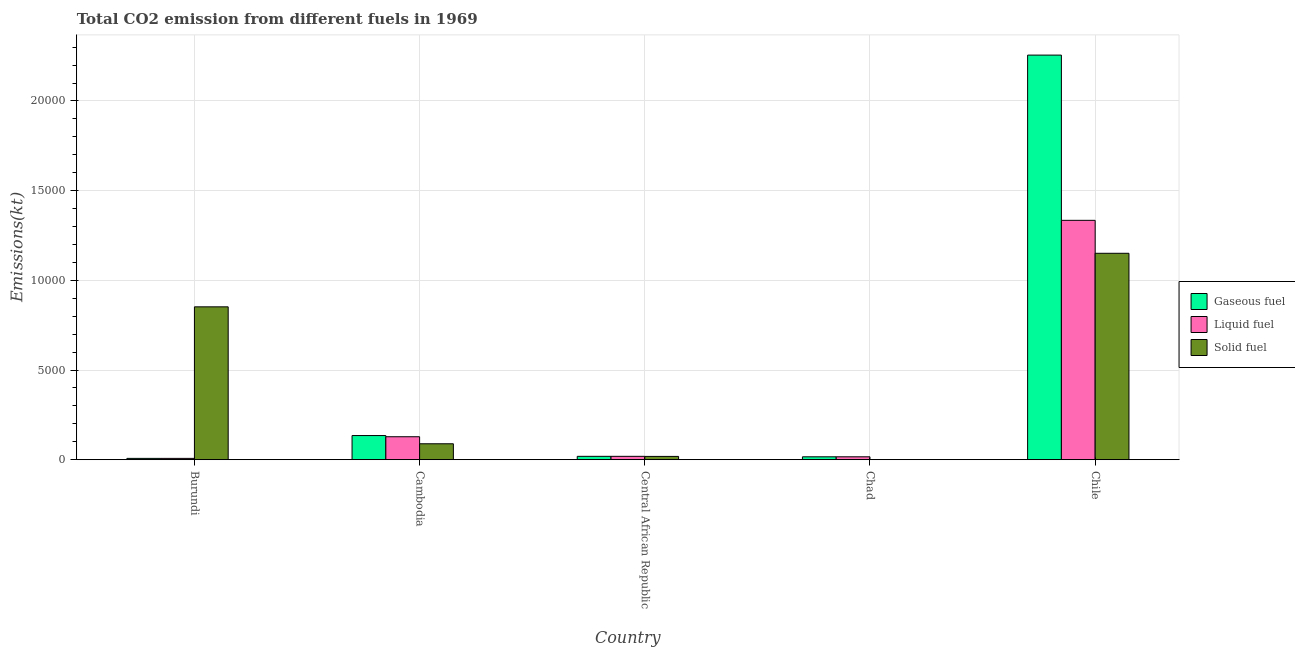How many different coloured bars are there?
Provide a short and direct response. 3. Are the number of bars per tick equal to the number of legend labels?
Keep it short and to the point. Yes. How many bars are there on the 2nd tick from the right?
Your response must be concise. 3. What is the amount of co2 emissions from solid fuel in Chile?
Your answer should be compact. 1.15e+04. Across all countries, what is the maximum amount of co2 emissions from solid fuel?
Your answer should be very brief. 1.15e+04. Across all countries, what is the minimum amount of co2 emissions from gaseous fuel?
Keep it short and to the point. 73.34. In which country was the amount of co2 emissions from gaseous fuel maximum?
Keep it short and to the point. Chile. In which country was the amount of co2 emissions from gaseous fuel minimum?
Your answer should be very brief. Burundi. What is the total amount of co2 emissions from liquid fuel in the graph?
Your answer should be very brief. 1.50e+04. What is the difference between the amount of co2 emissions from solid fuel in Central African Republic and that in Chile?
Ensure brevity in your answer.  -1.13e+04. What is the difference between the amount of co2 emissions from liquid fuel in Cambodia and the amount of co2 emissions from solid fuel in Burundi?
Offer a very short reply. -7242.33. What is the average amount of co2 emissions from solid fuel per country?
Keep it short and to the point. 4220.72. What is the difference between the amount of co2 emissions from gaseous fuel and amount of co2 emissions from solid fuel in Burundi?
Your answer should be very brief. -8448.77. In how many countries, is the amount of co2 emissions from liquid fuel greater than 19000 kt?
Provide a short and direct response. 0. What is the ratio of the amount of co2 emissions from gaseous fuel in Cambodia to that in Central African Republic?
Offer a terse response. 7.2. What is the difference between the highest and the second highest amount of co2 emissions from gaseous fuel?
Your answer should be very brief. 2.12e+04. What is the difference between the highest and the lowest amount of co2 emissions from liquid fuel?
Keep it short and to the point. 1.33e+04. What does the 1st bar from the left in Central African Republic represents?
Your answer should be very brief. Gaseous fuel. What does the 1st bar from the right in Cambodia represents?
Provide a short and direct response. Solid fuel. Is it the case that in every country, the sum of the amount of co2 emissions from gaseous fuel and amount of co2 emissions from liquid fuel is greater than the amount of co2 emissions from solid fuel?
Offer a terse response. No. How many bars are there?
Give a very brief answer. 15. How many countries are there in the graph?
Your response must be concise. 5. Does the graph contain any zero values?
Offer a terse response. No. Does the graph contain grids?
Your answer should be very brief. Yes. Where does the legend appear in the graph?
Keep it short and to the point. Center right. How many legend labels are there?
Your answer should be compact. 3. How are the legend labels stacked?
Offer a terse response. Vertical. What is the title of the graph?
Your response must be concise. Total CO2 emission from different fuels in 1969. What is the label or title of the X-axis?
Your answer should be very brief. Country. What is the label or title of the Y-axis?
Provide a short and direct response. Emissions(kt). What is the Emissions(kt) in Gaseous fuel in Burundi?
Your answer should be very brief. 73.34. What is the Emissions(kt) in Liquid fuel in Burundi?
Your answer should be very brief. 73.34. What is the Emissions(kt) of Solid fuel in Burundi?
Ensure brevity in your answer.  8522.11. What is the Emissions(kt) of Gaseous fuel in Cambodia?
Provide a short and direct response. 1345.79. What is the Emissions(kt) of Liquid fuel in Cambodia?
Offer a very short reply. 1279.78. What is the Emissions(kt) in Solid fuel in Cambodia?
Offer a very short reply. 887.41. What is the Emissions(kt) in Gaseous fuel in Central African Republic?
Make the answer very short. 187.02. What is the Emissions(kt) in Liquid fuel in Central African Republic?
Offer a terse response. 187.02. What is the Emissions(kt) of Solid fuel in Central African Republic?
Your answer should be compact. 183.35. What is the Emissions(kt) of Gaseous fuel in Chad?
Give a very brief answer. 161.35. What is the Emissions(kt) of Liquid fuel in Chad?
Your answer should be compact. 161.35. What is the Emissions(kt) of Solid fuel in Chad?
Keep it short and to the point. 3.67. What is the Emissions(kt) in Gaseous fuel in Chile?
Give a very brief answer. 2.26e+04. What is the Emissions(kt) of Liquid fuel in Chile?
Offer a terse response. 1.33e+04. What is the Emissions(kt) of Solid fuel in Chile?
Offer a very short reply. 1.15e+04. Across all countries, what is the maximum Emissions(kt) of Gaseous fuel?
Provide a succinct answer. 2.26e+04. Across all countries, what is the maximum Emissions(kt) of Liquid fuel?
Provide a succinct answer. 1.33e+04. Across all countries, what is the maximum Emissions(kt) of Solid fuel?
Give a very brief answer. 1.15e+04. Across all countries, what is the minimum Emissions(kt) of Gaseous fuel?
Your response must be concise. 73.34. Across all countries, what is the minimum Emissions(kt) in Liquid fuel?
Give a very brief answer. 73.34. Across all countries, what is the minimum Emissions(kt) in Solid fuel?
Give a very brief answer. 3.67. What is the total Emissions(kt) in Gaseous fuel in the graph?
Your answer should be very brief. 2.43e+04. What is the total Emissions(kt) of Liquid fuel in the graph?
Your answer should be very brief. 1.50e+04. What is the total Emissions(kt) of Solid fuel in the graph?
Keep it short and to the point. 2.11e+04. What is the difference between the Emissions(kt) of Gaseous fuel in Burundi and that in Cambodia?
Provide a short and direct response. -1272.45. What is the difference between the Emissions(kt) of Liquid fuel in Burundi and that in Cambodia?
Your answer should be compact. -1206.44. What is the difference between the Emissions(kt) in Solid fuel in Burundi and that in Cambodia?
Your answer should be compact. 7634.69. What is the difference between the Emissions(kt) of Gaseous fuel in Burundi and that in Central African Republic?
Offer a terse response. -113.68. What is the difference between the Emissions(kt) of Liquid fuel in Burundi and that in Central African Republic?
Your answer should be very brief. -113.68. What is the difference between the Emissions(kt) of Solid fuel in Burundi and that in Central African Republic?
Your answer should be compact. 8338.76. What is the difference between the Emissions(kt) in Gaseous fuel in Burundi and that in Chad?
Make the answer very short. -88.01. What is the difference between the Emissions(kt) in Liquid fuel in Burundi and that in Chad?
Give a very brief answer. -88.01. What is the difference between the Emissions(kt) of Solid fuel in Burundi and that in Chad?
Ensure brevity in your answer.  8518.44. What is the difference between the Emissions(kt) in Gaseous fuel in Burundi and that in Chile?
Offer a terse response. -2.25e+04. What is the difference between the Emissions(kt) in Liquid fuel in Burundi and that in Chile?
Give a very brief answer. -1.33e+04. What is the difference between the Emissions(kt) of Solid fuel in Burundi and that in Chile?
Make the answer very short. -2984.94. What is the difference between the Emissions(kt) in Gaseous fuel in Cambodia and that in Central African Republic?
Your response must be concise. 1158.77. What is the difference between the Emissions(kt) in Liquid fuel in Cambodia and that in Central African Republic?
Offer a terse response. 1092.77. What is the difference between the Emissions(kt) of Solid fuel in Cambodia and that in Central African Republic?
Offer a very short reply. 704.06. What is the difference between the Emissions(kt) of Gaseous fuel in Cambodia and that in Chad?
Ensure brevity in your answer.  1184.44. What is the difference between the Emissions(kt) of Liquid fuel in Cambodia and that in Chad?
Offer a terse response. 1118.43. What is the difference between the Emissions(kt) in Solid fuel in Cambodia and that in Chad?
Offer a terse response. 883.75. What is the difference between the Emissions(kt) in Gaseous fuel in Cambodia and that in Chile?
Your answer should be compact. -2.12e+04. What is the difference between the Emissions(kt) of Liquid fuel in Cambodia and that in Chile?
Your answer should be very brief. -1.21e+04. What is the difference between the Emissions(kt) in Solid fuel in Cambodia and that in Chile?
Offer a very short reply. -1.06e+04. What is the difference between the Emissions(kt) of Gaseous fuel in Central African Republic and that in Chad?
Your answer should be compact. 25.67. What is the difference between the Emissions(kt) in Liquid fuel in Central African Republic and that in Chad?
Offer a very short reply. 25.67. What is the difference between the Emissions(kt) in Solid fuel in Central African Republic and that in Chad?
Provide a succinct answer. 179.68. What is the difference between the Emissions(kt) in Gaseous fuel in Central African Republic and that in Chile?
Ensure brevity in your answer.  -2.24e+04. What is the difference between the Emissions(kt) in Liquid fuel in Central African Republic and that in Chile?
Make the answer very short. -1.32e+04. What is the difference between the Emissions(kt) of Solid fuel in Central African Republic and that in Chile?
Provide a succinct answer. -1.13e+04. What is the difference between the Emissions(kt) of Gaseous fuel in Chad and that in Chile?
Give a very brief answer. -2.24e+04. What is the difference between the Emissions(kt) of Liquid fuel in Chad and that in Chile?
Make the answer very short. -1.32e+04. What is the difference between the Emissions(kt) of Solid fuel in Chad and that in Chile?
Your answer should be very brief. -1.15e+04. What is the difference between the Emissions(kt) in Gaseous fuel in Burundi and the Emissions(kt) in Liquid fuel in Cambodia?
Provide a short and direct response. -1206.44. What is the difference between the Emissions(kt) in Gaseous fuel in Burundi and the Emissions(kt) in Solid fuel in Cambodia?
Provide a succinct answer. -814.07. What is the difference between the Emissions(kt) in Liquid fuel in Burundi and the Emissions(kt) in Solid fuel in Cambodia?
Your answer should be compact. -814.07. What is the difference between the Emissions(kt) of Gaseous fuel in Burundi and the Emissions(kt) of Liquid fuel in Central African Republic?
Offer a very short reply. -113.68. What is the difference between the Emissions(kt) in Gaseous fuel in Burundi and the Emissions(kt) in Solid fuel in Central African Republic?
Ensure brevity in your answer.  -110.01. What is the difference between the Emissions(kt) in Liquid fuel in Burundi and the Emissions(kt) in Solid fuel in Central African Republic?
Provide a short and direct response. -110.01. What is the difference between the Emissions(kt) of Gaseous fuel in Burundi and the Emissions(kt) of Liquid fuel in Chad?
Your response must be concise. -88.01. What is the difference between the Emissions(kt) in Gaseous fuel in Burundi and the Emissions(kt) in Solid fuel in Chad?
Provide a succinct answer. 69.67. What is the difference between the Emissions(kt) of Liquid fuel in Burundi and the Emissions(kt) of Solid fuel in Chad?
Your answer should be compact. 69.67. What is the difference between the Emissions(kt) of Gaseous fuel in Burundi and the Emissions(kt) of Liquid fuel in Chile?
Make the answer very short. -1.33e+04. What is the difference between the Emissions(kt) in Gaseous fuel in Burundi and the Emissions(kt) in Solid fuel in Chile?
Keep it short and to the point. -1.14e+04. What is the difference between the Emissions(kt) of Liquid fuel in Burundi and the Emissions(kt) of Solid fuel in Chile?
Provide a succinct answer. -1.14e+04. What is the difference between the Emissions(kt) of Gaseous fuel in Cambodia and the Emissions(kt) of Liquid fuel in Central African Republic?
Provide a short and direct response. 1158.77. What is the difference between the Emissions(kt) of Gaseous fuel in Cambodia and the Emissions(kt) of Solid fuel in Central African Republic?
Provide a short and direct response. 1162.44. What is the difference between the Emissions(kt) in Liquid fuel in Cambodia and the Emissions(kt) in Solid fuel in Central African Republic?
Make the answer very short. 1096.43. What is the difference between the Emissions(kt) in Gaseous fuel in Cambodia and the Emissions(kt) in Liquid fuel in Chad?
Provide a succinct answer. 1184.44. What is the difference between the Emissions(kt) of Gaseous fuel in Cambodia and the Emissions(kt) of Solid fuel in Chad?
Keep it short and to the point. 1342.12. What is the difference between the Emissions(kt) of Liquid fuel in Cambodia and the Emissions(kt) of Solid fuel in Chad?
Provide a short and direct response. 1276.12. What is the difference between the Emissions(kt) in Gaseous fuel in Cambodia and the Emissions(kt) in Liquid fuel in Chile?
Your answer should be very brief. -1.20e+04. What is the difference between the Emissions(kt) in Gaseous fuel in Cambodia and the Emissions(kt) in Solid fuel in Chile?
Ensure brevity in your answer.  -1.02e+04. What is the difference between the Emissions(kt) in Liquid fuel in Cambodia and the Emissions(kt) in Solid fuel in Chile?
Your answer should be compact. -1.02e+04. What is the difference between the Emissions(kt) in Gaseous fuel in Central African Republic and the Emissions(kt) in Liquid fuel in Chad?
Your answer should be compact. 25.67. What is the difference between the Emissions(kt) in Gaseous fuel in Central African Republic and the Emissions(kt) in Solid fuel in Chad?
Ensure brevity in your answer.  183.35. What is the difference between the Emissions(kt) of Liquid fuel in Central African Republic and the Emissions(kt) of Solid fuel in Chad?
Your answer should be compact. 183.35. What is the difference between the Emissions(kt) of Gaseous fuel in Central African Republic and the Emissions(kt) of Liquid fuel in Chile?
Ensure brevity in your answer.  -1.32e+04. What is the difference between the Emissions(kt) in Gaseous fuel in Central African Republic and the Emissions(kt) in Solid fuel in Chile?
Offer a terse response. -1.13e+04. What is the difference between the Emissions(kt) in Liquid fuel in Central African Republic and the Emissions(kt) in Solid fuel in Chile?
Your answer should be very brief. -1.13e+04. What is the difference between the Emissions(kt) in Gaseous fuel in Chad and the Emissions(kt) in Liquid fuel in Chile?
Provide a short and direct response. -1.32e+04. What is the difference between the Emissions(kt) in Gaseous fuel in Chad and the Emissions(kt) in Solid fuel in Chile?
Provide a succinct answer. -1.13e+04. What is the difference between the Emissions(kt) of Liquid fuel in Chad and the Emissions(kt) of Solid fuel in Chile?
Your answer should be very brief. -1.13e+04. What is the average Emissions(kt) of Gaseous fuel per country?
Offer a terse response. 4864.64. What is the average Emissions(kt) of Liquid fuel per country?
Make the answer very short. 3009.14. What is the average Emissions(kt) of Solid fuel per country?
Give a very brief answer. 4220.72. What is the difference between the Emissions(kt) of Gaseous fuel and Emissions(kt) of Solid fuel in Burundi?
Keep it short and to the point. -8448.77. What is the difference between the Emissions(kt) of Liquid fuel and Emissions(kt) of Solid fuel in Burundi?
Keep it short and to the point. -8448.77. What is the difference between the Emissions(kt) of Gaseous fuel and Emissions(kt) of Liquid fuel in Cambodia?
Make the answer very short. 66.01. What is the difference between the Emissions(kt) of Gaseous fuel and Emissions(kt) of Solid fuel in Cambodia?
Offer a terse response. 458.38. What is the difference between the Emissions(kt) in Liquid fuel and Emissions(kt) in Solid fuel in Cambodia?
Keep it short and to the point. 392.37. What is the difference between the Emissions(kt) of Gaseous fuel and Emissions(kt) of Liquid fuel in Central African Republic?
Your answer should be very brief. 0. What is the difference between the Emissions(kt) in Gaseous fuel and Emissions(kt) in Solid fuel in Central African Republic?
Your response must be concise. 3.67. What is the difference between the Emissions(kt) in Liquid fuel and Emissions(kt) in Solid fuel in Central African Republic?
Provide a short and direct response. 3.67. What is the difference between the Emissions(kt) in Gaseous fuel and Emissions(kt) in Solid fuel in Chad?
Offer a very short reply. 157.68. What is the difference between the Emissions(kt) in Liquid fuel and Emissions(kt) in Solid fuel in Chad?
Your answer should be very brief. 157.68. What is the difference between the Emissions(kt) in Gaseous fuel and Emissions(kt) in Liquid fuel in Chile?
Your answer should be very brief. 9211.5. What is the difference between the Emissions(kt) in Gaseous fuel and Emissions(kt) in Solid fuel in Chile?
Provide a succinct answer. 1.10e+04. What is the difference between the Emissions(kt) in Liquid fuel and Emissions(kt) in Solid fuel in Chile?
Your response must be concise. 1837.17. What is the ratio of the Emissions(kt) in Gaseous fuel in Burundi to that in Cambodia?
Ensure brevity in your answer.  0.05. What is the ratio of the Emissions(kt) of Liquid fuel in Burundi to that in Cambodia?
Provide a short and direct response. 0.06. What is the ratio of the Emissions(kt) in Solid fuel in Burundi to that in Cambodia?
Provide a short and direct response. 9.6. What is the ratio of the Emissions(kt) in Gaseous fuel in Burundi to that in Central African Republic?
Make the answer very short. 0.39. What is the ratio of the Emissions(kt) in Liquid fuel in Burundi to that in Central African Republic?
Provide a succinct answer. 0.39. What is the ratio of the Emissions(kt) of Solid fuel in Burundi to that in Central African Republic?
Give a very brief answer. 46.48. What is the ratio of the Emissions(kt) in Gaseous fuel in Burundi to that in Chad?
Provide a short and direct response. 0.45. What is the ratio of the Emissions(kt) of Liquid fuel in Burundi to that in Chad?
Offer a terse response. 0.45. What is the ratio of the Emissions(kt) of Solid fuel in Burundi to that in Chad?
Your answer should be very brief. 2324. What is the ratio of the Emissions(kt) in Gaseous fuel in Burundi to that in Chile?
Offer a terse response. 0. What is the ratio of the Emissions(kt) of Liquid fuel in Burundi to that in Chile?
Make the answer very short. 0.01. What is the ratio of the Emissions(kt) of Solid fuel in Burundi to that in Chile?
Your answer should be compact. 0.74. What is the ratio of the Emissions(kt) of Gaseous fuel in Cambodia to that in Central African Republic?
Your answer should be compact. 7.2. What is the ratio of the Emissions(kt) in Liquid fuel in Cambodia to that in Central African Republic?
Your answer should be very brief. 6.84. What is the ratio of the Emissions(kt) in Solid fuel in Cambodia to that in Central African Republic?
Your response must be concise. 4.84. What is the ratio of the Emissions(kt) in Gaseous fuel in Cambodia to that in Chad?
Ensure brevity in your answer.  8.34. What is the ratio of the Emissions(kt) in Liquid fuel in Cambodia to that in Chad?
Your answer should be very brief. 7.93. What is the ratio of the Emissions(kt) of Solid fuel in Cambodia to that in Chad?
Give a very brief answer. 242. What is the ratio of the Emissions(kt) in Gaseous fuel in Cambodia to that in Chile?
Ensure brevity in your answer.  0.06. What is the ratio of the Emissions(kt) of Liquid fuel in Cambodia to that in Chile?
Provide a short and direct response. 0.1. What is the ratio of the Emissions(kt) in Solid fuel in Cambodia to that in Chile?
Ensure brevity in your answer.  0.08. What is the ratio of the Emissions(kt) of Gaseous fuel in Central African Republic to that in Chad?
Keep it short and to the point. 1.16. What is the ratio of the Emissions(kt) in Liquid fuel in Central African Republic to that in Chad?
Offer a very short reply. 1.16. What is the ratio of the Emissions(kt) in Solid fuel in Central African Republic to that in Chad?
Ensure brevity in your answer.  50. What is the ratio of the Emissions(kt) in Gaseous fuel in Central African Republic to that in Chile?
Offer a very short reply. 0.01. What is the ratio of the Emissions(kt) in Liquid fuel in Central African Republic to that in Chile?
Provide a succinct answer. 0.01. What is the ratio of the Emissions(kt) of Solid fuel in Central African Republic to that in Chile?
Ensure brevity in your answer.  0.02. What is the ratio of the Emissions(kt) in Gaseous fuel in Chad to that in Chile?
Make the answer very short. 0.01. What is the ratio of the Emissions(kt) in Liquid fuel in Chad to that in Chile?
Make the answer very short. 0.01. What is the ratio of the Emissions(kt) of Solid fuel in Chad to that in Chile?
Keep it short and to the point. 0. What is the difference between the highest and the second highest Emissions(kt) in Gaseous fuel?
Offer a terse response. 2.12e+04. What is the difference between the highest and the second highest Emissions(kt) of Liquid fuel?
Make the answer very short. 1.21e+04. What is the difference between the highest and the second highest Emissions(kt) of Solid fuel?
Your response must be concise. 2984.94. What is the difference between the highest and the lowest Emissions(kt) of Gaseous fuel?
Your response must be concise. 2.25e+04. What is the difference between the highest and the lowest Emissions(kt) in Liquid fuel?
Give a very brief answer. 1.33e+04. What is the difference between the highest and the lowest Emissions(kt) of Solid fuel?
Your answer should be compact. 1.15e+04. 